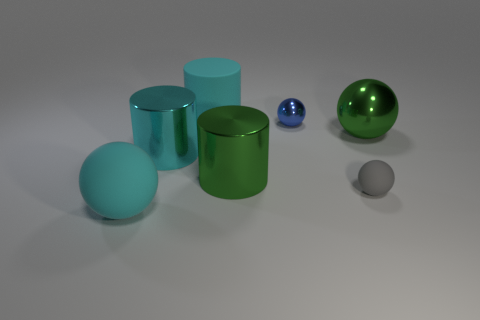Subtract all blue blocks. How many cyan cylinders are left? 2 Subtract all shiny cylinders. How many cylinders are left? 1 Subtract all green balls. How many balls are left? 3 Add 2 tiny blue metal objects. How many objects exist? 9 Subtract all purple balls. Subtract all brown cylinders. How many balls are left? 4 Subtract all balls. How many objects are left? 3 Add 4 rubber cylinders. How many rubber cylinders exist? 5 Subtract 1 blue spheres. How many objects are left? 6 Subtract all rubber cubes. Subtract all blue metal spheres. How many objects are left? 6 Add 4 blue metallic spheres. How many blue metallic spheres are left? 5 